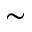<formula> <loc_0><loc_0><loc_500><loc_500>\sim</formula> 